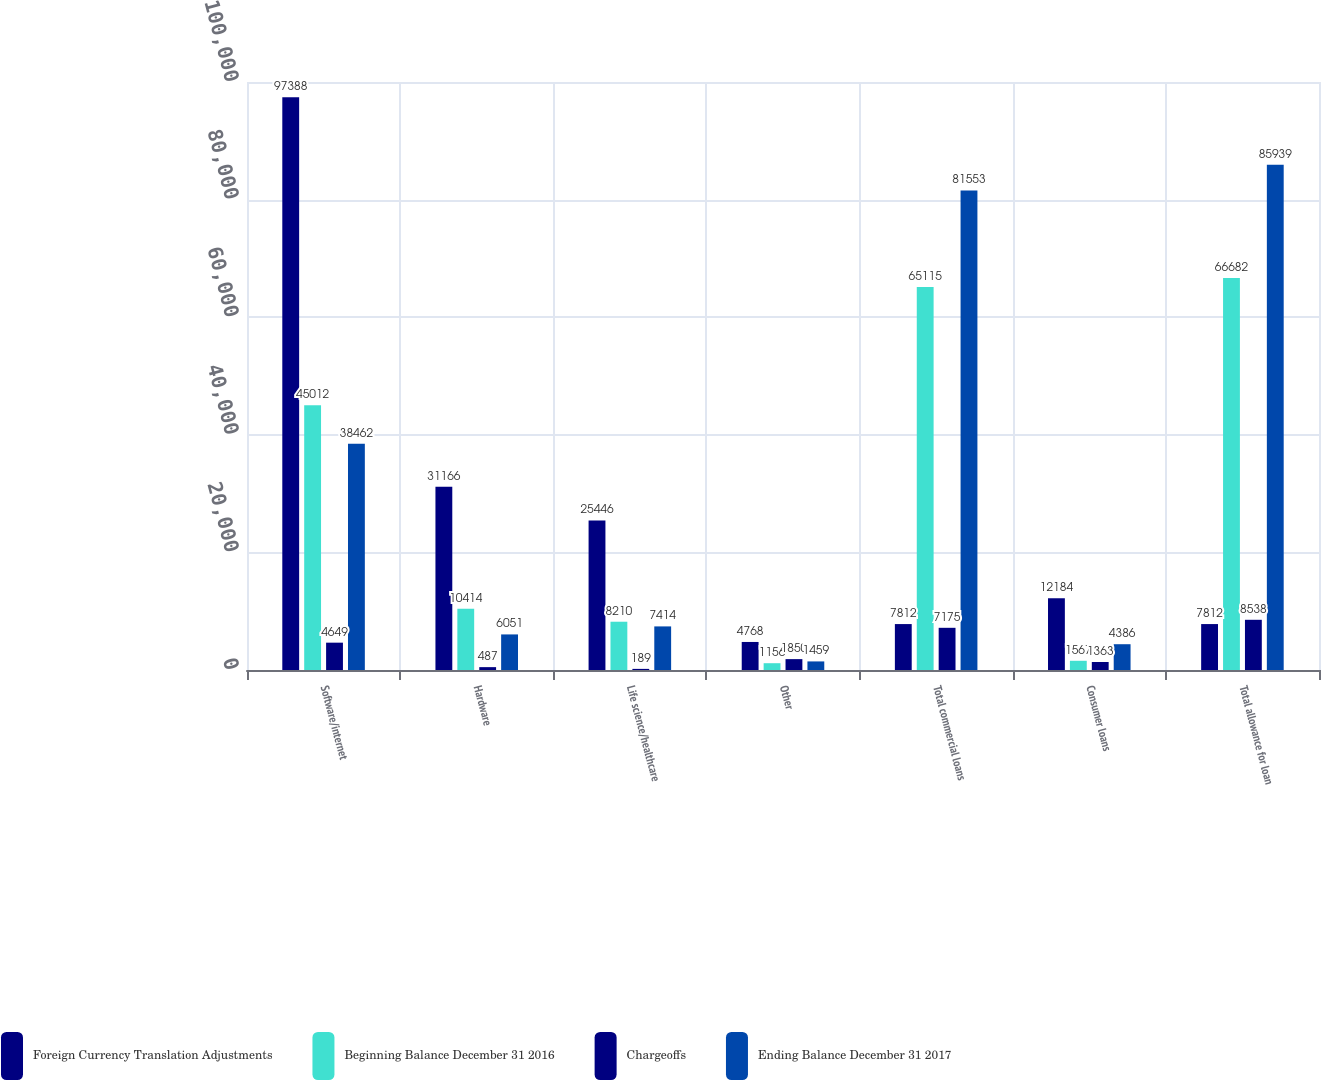Convert chart to OTSL. <chart><loc_0><loc_0><loc_500><loc_500><stacked_bar_chart><ecel><fcel>Software/internet<fcel>Hardware<fcel>Life science/healthcare<fcel>Other<fcel>Total commercial loans<fcel>Consumer loans<fcel>Total allowance for loan<nl><fcel>Foreign Currency Translation Adjustments<fcel>97388<fcel>31166<fcel>25446<fcel>4768<fcel>7812<fcel>12184<fcel>7812<nl><fcel>Beginning Balance December 31 2016<fcel>45012<fcel>10414<fcel>8210<fcel>1156<fcel>65115<fcel>1567<fcel>66682<nl><fcel>Chargeoffs<fcel>4649<fcel>487<fcel>189<fcel>1850<fcel>7175<fcel>1363<fcel>8538<nl><fcel>Ending Balance December 31 2017<fcel>38462<fcel>6051<fcel>7414<fcel>1459<fcel>81553<fcel>4386<fcel>85939<nl></chart> 